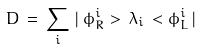Convert formula to latex. <formula><loc_0><loc_0><loc_500><loc_500>D \, = \, \sum _ { i } \, | \, \phi _ { R } ^ { i } > \, \lambda _ { i } \, < \phi _ { L } ^ { i } \, |</formula> 